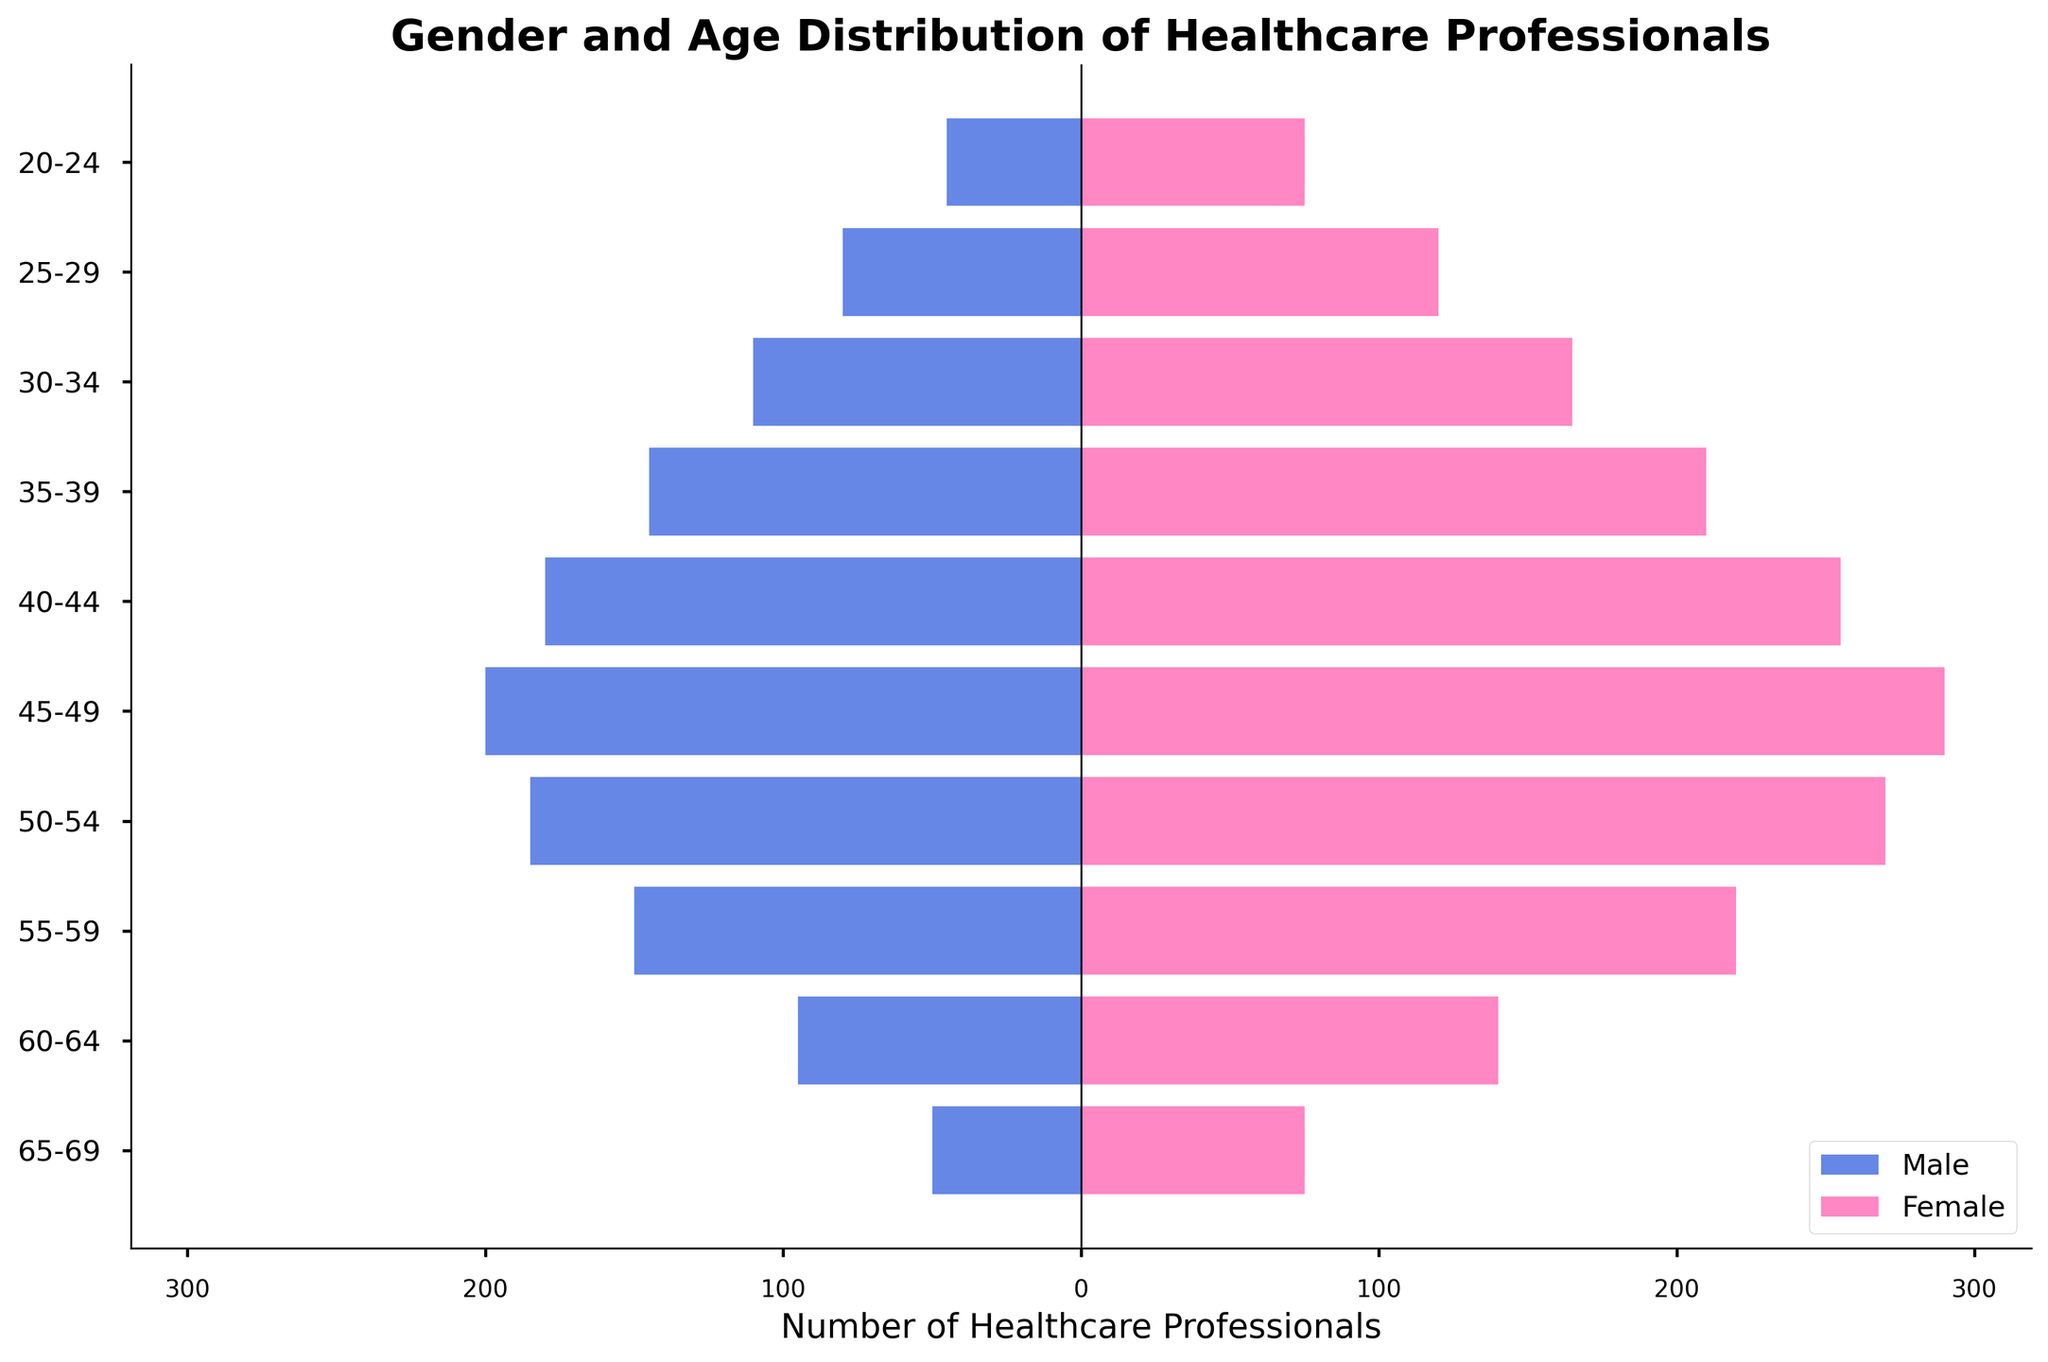What is the title of the plot? The title is typically located at the top of the figure. Here it is "Gender and Age Distribution of Healthcare Professionals."
Answer: Gender and Age Distribution of Healthcare Professionals Which age group has the highest number of female healthcare professionals? By referring to the bars representing females, the longest bar indicates the age group with the highest number of females. The longest female bar is at the 45-49 age group with 290 healthcare professionals.
Answer: 45-49 How many male healthcare professionals are there in the 60-64 age group? The bar corresponding to males in the 60-64 age group indicates the number, which is represented as a negative value. It shows 95 male healthcare professionals.
Answer: 95 What is the total number of healthcare professionals in the 55-59 age group? To find the total, add the number of male and female healthcare professionals in the 55-59 age group. Males are 150 and females are 220, so 150 + 220 = 370.
Answer: 370 Which age group has the smallest difference between the number of male and female healthcare professionals? Calculate the difference between the number of males and females for each age group and compare. The smallest differences are in the 65-69 age group (25) and 20-24 age group (30), with 65-69 having only a 25-person difference.
Answer: 65-69 How does the number of female healthcare professionals in the 40-44 age group compare to the number of male healthcare professionals in the 50-54 age group? Compare the two values directly. Females in 40-44 have 255, and males in 50-54 have 185, so 255 is greater than 185.
Answer: Greater How many females are there in total in the younger half of the age groups (20-44)? Add the number of females from the age groups 20-24, 25-29, 30-34, 35-39, and 40-44. So, it's 75 + 120 + 165 + 210 + 255 = 825.
Answer: 825 What is the general trend in the number of male healthcare professionals as age increases? Examine the lengths of the bars representing males. They generally increase until the age group 45-49 and then start decreasing.
Answer: Increase until 45-49, then decrease Which age group has roughly equal numbers of male and female healthcare professionals? Identify age groups where the lengths of male (negative) and female (positive) bars are close to each other. 65-69 age group has males (50) and females (75) which are relatively close.
Answer: 65-69 What can you infer about the gender distribution within the age group 30-34? Compare the lengths of the bars for males and females in the 30-34 age group. Females (165) significantly outnumber males (110).
Answer: Females significantly outnumber males 